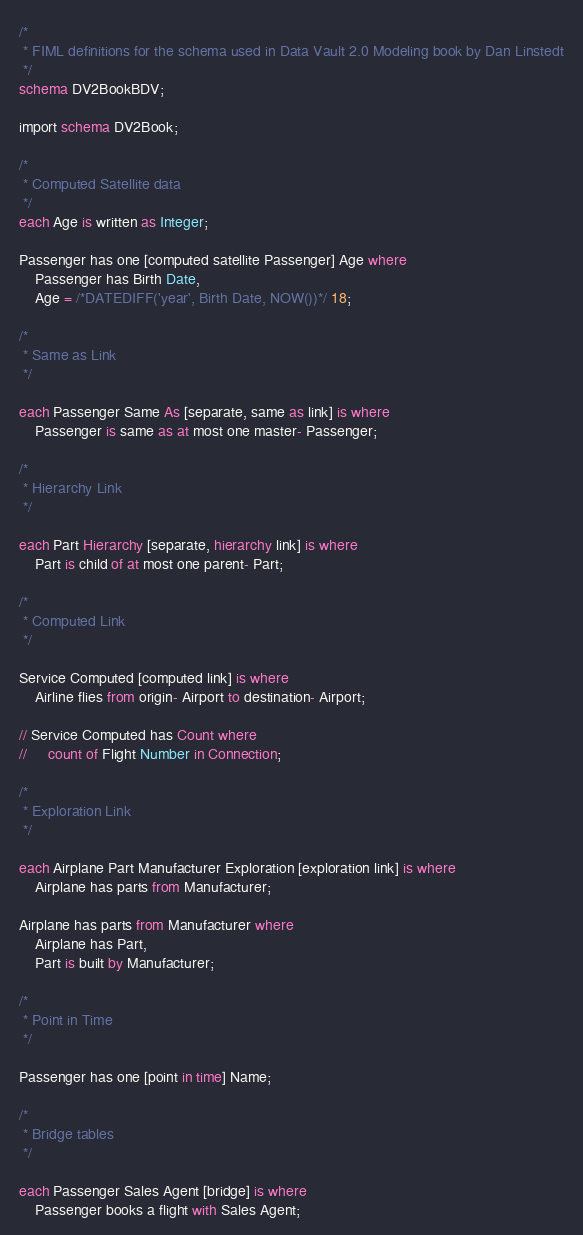Convert code to text. <code><loc_0><loc_0><loc_500><loc_500><_SQL_>/*
 * FIML definitions for the schema used in Data Vault 2.0 Modeling book by Dan Linstedt
 */
schema DV2BookBDV;

import schema DV2Book;

/*
 * Computed Satellite data
 */
each Age is written as Integer;
    
Passenger has one [computed satellite Passenger] Age where
    Passenger has Birth Date,
    Age = /*DATEDIFF('year', Birth Date, NOW())*/ 18;

/*
 * Same as Link
 */

each Passenger Same As [separate, same as link] is where
    Passenger is same as at most one master- Passenger;

/*
 * Hierarchy Link
 */

each Part Hierarchy [separate, hierarchy link] is where
    Part is child of at most one parent- Part;

/*
 * Computed Link
 */

Service Computed [computed link] is where
    Airline flies from origin- Airport to destination- Airport;
    
// Service Computed has Count where
//     count of Flight Number in Connection;
    
/*
 * Exploration Link
 */

each Airplane Part Manufacturer Exploration [exploration link] is where
    Airplane has parts from Manufacturer;

Airplane has parts from Manufacturer where
    Airplane has Part,
    Part is built by Manufacturer;

/*
 * Point in Time
 */

Passenger has one [point in time] Name;

/*
 * Bridge tables
 */

each Passenger Sales Agent [bridge] is where
    Passenger books a flight with Sales Agent;
</code> 